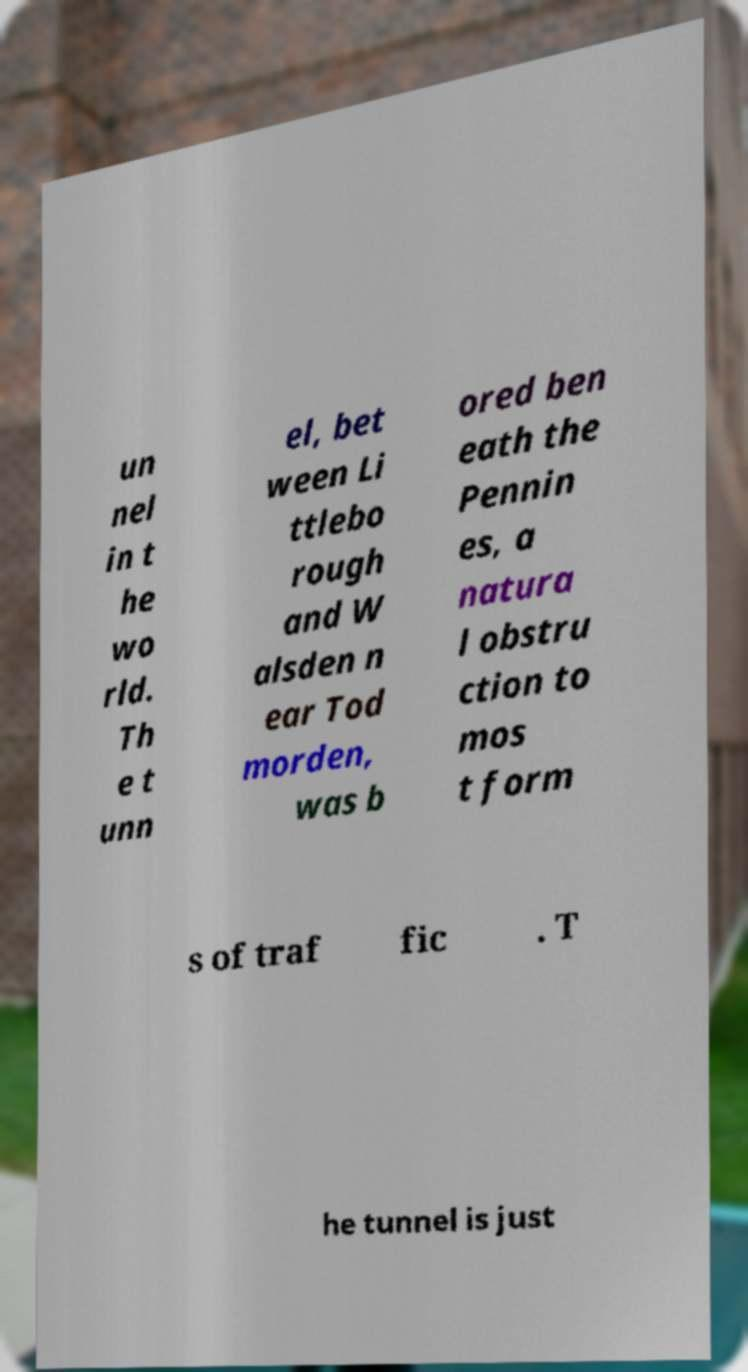I need the written content from this picture converted into text. Can you do that? un nel in t he wo rld. Th e t unn el, bet ween Li ttlebo rough and W alsden n ear Tod morden, was b ored ben eath the Pennin es, a natura l obstru ction to mos t form s of traf fic . T he tunnel is just 